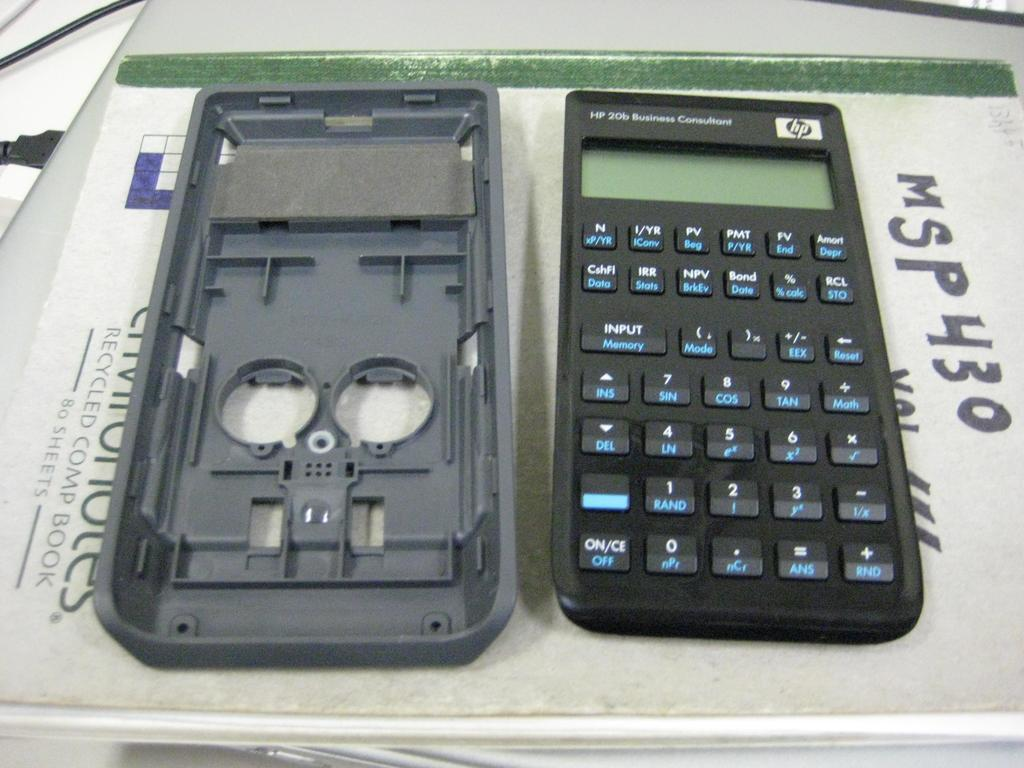Provide a one-sentence caption for the provided image. A calculator on top of a recycled comp book. 